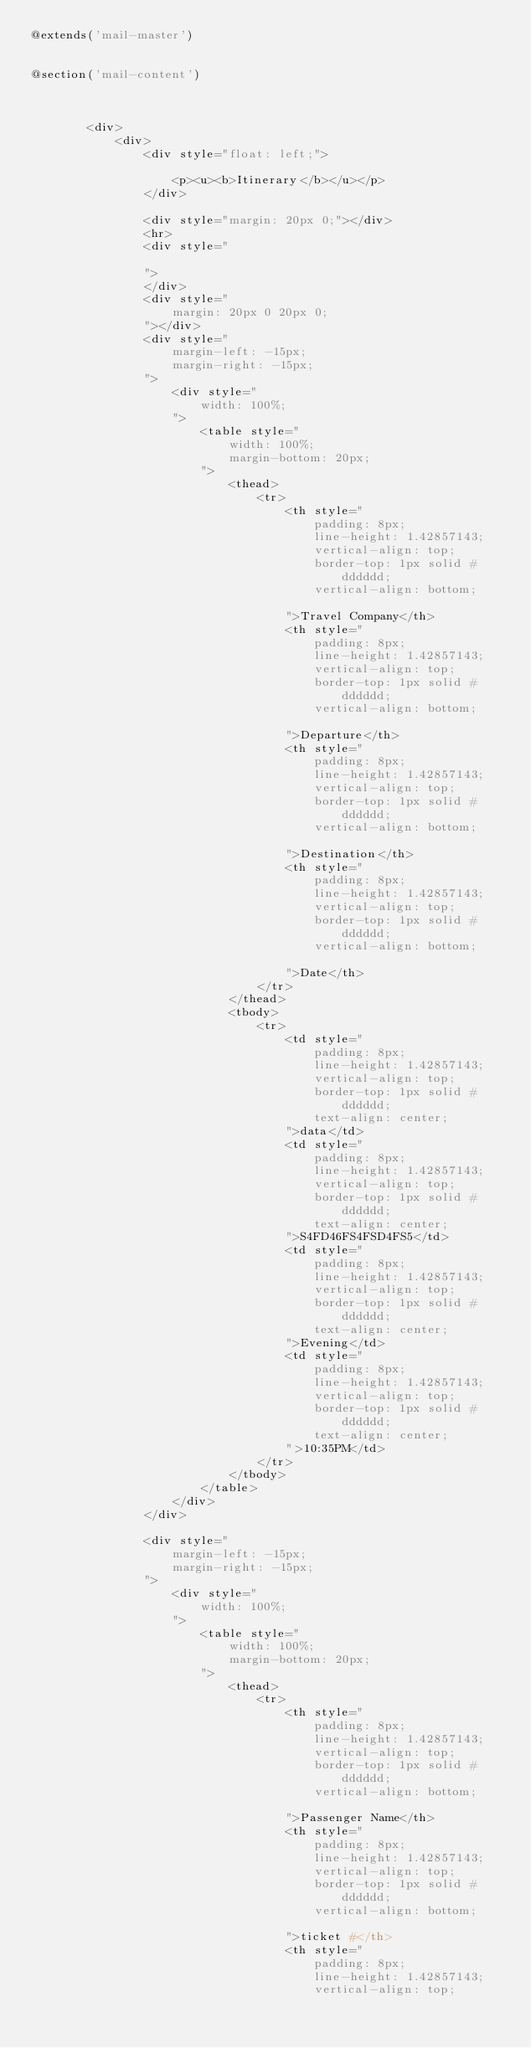Convert code to text. <code><loc_0><loc_0><loc_500><loc_500><_PHP_>@extends('mail-master')


@section('mail-content')

    
    
        <div>
            <div>
                <div style="float: left;">
                    
                    <p><u><b>Itinerary</b></u></p>
                </div>
                
                <div style="margin: 20px 0;"></div>
                <hr>
                <div style="
                   
                ">
                </div>
                <div style="
                    margin: 20px 0 20px 0;
                "></div>
                <div style="
                    margin-left: -15px;
                    margin-right: -15px;
                ">
                    <div style="
                        width: 100%;
                    ">
                        <table style="
                            width: 100%;
                            margin-bottom: 20px;
                        ">
                            <thead>
                                <tr>
                                    <th style="
                                        padding: 8px;
                                        line-height: 1.42857143;
                                        vertical-align: top;
                                        border-top: 1px solid #dddddd;
                                        vertical-align: bottom;
                                        
                                    ">Travel Company</th>
                                    <th style="
                                        padding: 8px;
                                        line-height: 1.42857143;
                                        vertical-align: top;
                                        border-top: 1px solid #dddddd;
                                        vertical-align: bottom;
                                        
                                    ">Departure</th>
                                    <th style="
                                        padding: 8px;
                                        line-height: 1.42857143;
                                        vertical-align: top;
                                        border-top: 1px solid #dddddd;
                                        vertical-align: bottom;
                                        
                                    ">Destination</th>
                                    <th style="
                                        padding: 8px;
                                        line-height: 1.42857143;
                                        vertical-align: top;
                                        border-top: 1px solid #dddddd;
                                        vertical-align: bottom;
                                        
                                    ">Date</th>
                                </tr>
                            </thead>
                            <tbody>
                                <tr>
                                    <td style="
                                        padding: 8px;
                                        line-height: 1.42857143;
                                        vertical-align: top;
                                        border-top: 1px solid #dddddd;
                                        text-align: center;
                                    ">data</td>
                                    <td style="
                                        padding: 8px;
                                        line-height: 1.42857143;
                                        vertical-align: top;
                                        border-top: 1px solid #dddddd;
                                        text-align: center;
                                    ">S4FD46FS4FSD4FS5</td>
                                    <td style="
                                        padding: 8px;
                                        line-height: 1.42857143;
                                        vertical-align: top;
                                        border-top: 1px solid #dddddd;
                                        text-align: center;
                                    ">Evening</td>
                                    <td style="
                                        padding: 8px;
                                        line-height: 1.42857143;
                                        vertical-align: top;
                                        border-top: 1px solid #dddddd;
                                        text-align: center;
                                    ">10:35PM</td>
                                </tr>
                            </tbody>
                        </table>
                    </div>
                </div>
                
                <div style="
                    margin-left: -15px;
                    margin-right: -15px;
                ">
                    <div style="
                        width: 100%;
                    ">
                        <table style="
                            width: 100%;
                            margin-bottom: 20px;
                        ">
                            <thead>
                                <tr>
                                    <th style="
                                        padding: 8px;
                                        line-height: 1.42857143;
                                        vertical-align: top;
                                        border-top: 1px solid #dddddd;
                                        vertical-align: bottom;
                                        
                                    ">Passenger Name</th>
                                    <th style="
                                        padding: 8px;
                                        line-height: 1.42857143;
                                        vertical-align: top;
                                        border-top: 1px solid #dddddd;
                                        vertical-align: bottom;
                                        
                                    ">ticket #</th>
                                    <th style="
                                        padding: 8px;
                                        line-height: 1.42857143;
                                        vertical-align: top;</code> 